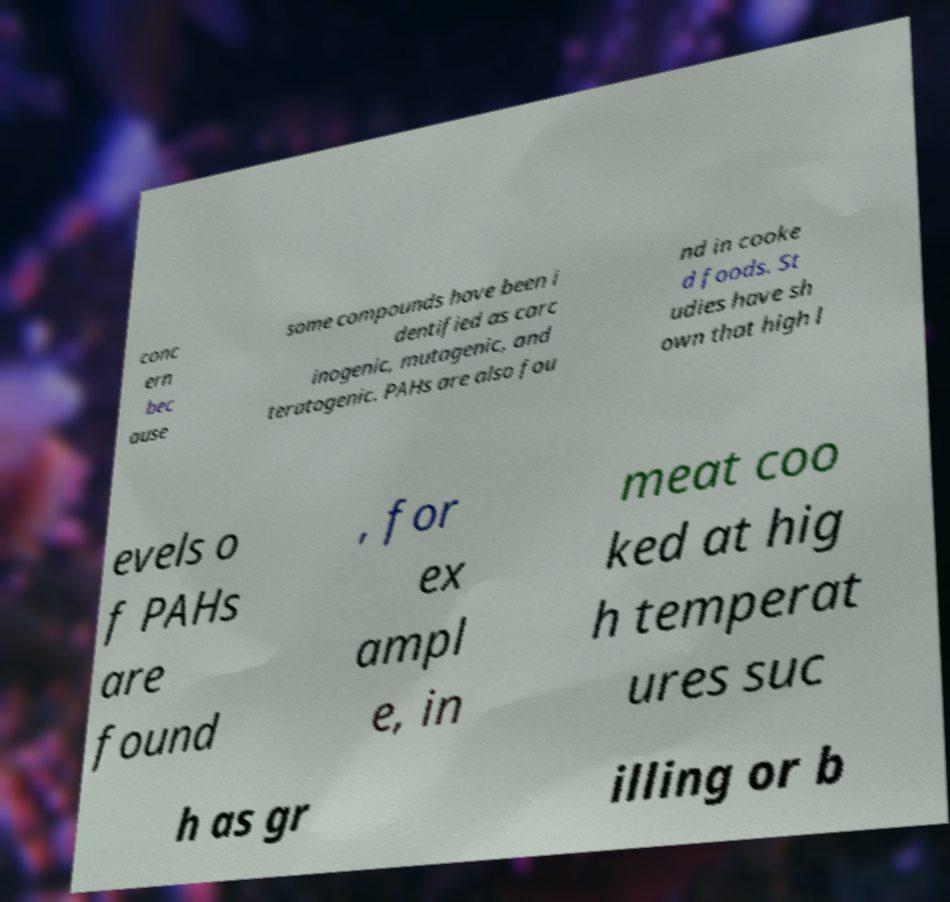Please read and relay the text visible in this image. What does it say? conc ern bec ause some compounds have been i dentified as carc inogenic, mutagenic, and teratogenic. PAHs are also fou nd in cooke d foods. St udies have sh own that high l evels o f PAHs are found , for ex ampl e, in meat coo ked at hig h temperat ures suc h as gr illing or b 